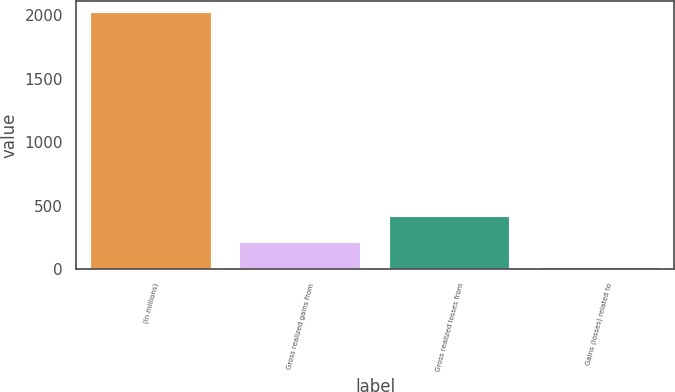Convert chart. <chart><loc_0><loc_0><loc_500><loc_500><bar_chart><fcel>(In millions)<fcel>Gross realized gains from<fcel>Gross realized losses from<fcel>Gains (losses) related to<nl><fcel>2015<fcel>206.9<fcel>407.8<fcel>6<nl></chart> 